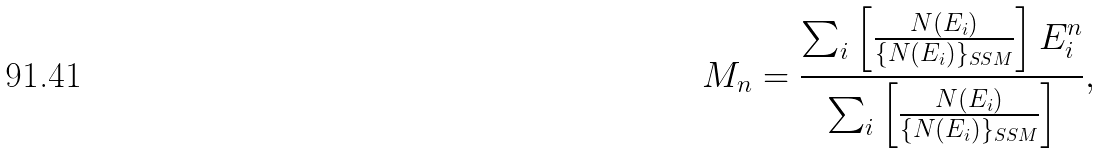<formula> <loc_0><loc_0><loc_500><loc_500>M _ { n } = \frac { \sum _ { i } \left [ \frac { N ( E _ { i } ) } { \{ N ( E _ { i } ) \} _ { S S M } } \right ] E _ { i } ^ { n } } { \sum _ { i } \left [ \frac { N ( E _ { i } ) } { \{ N ( E _ { i } ) \} _ { S S M } } \right ] } ,</formula> 